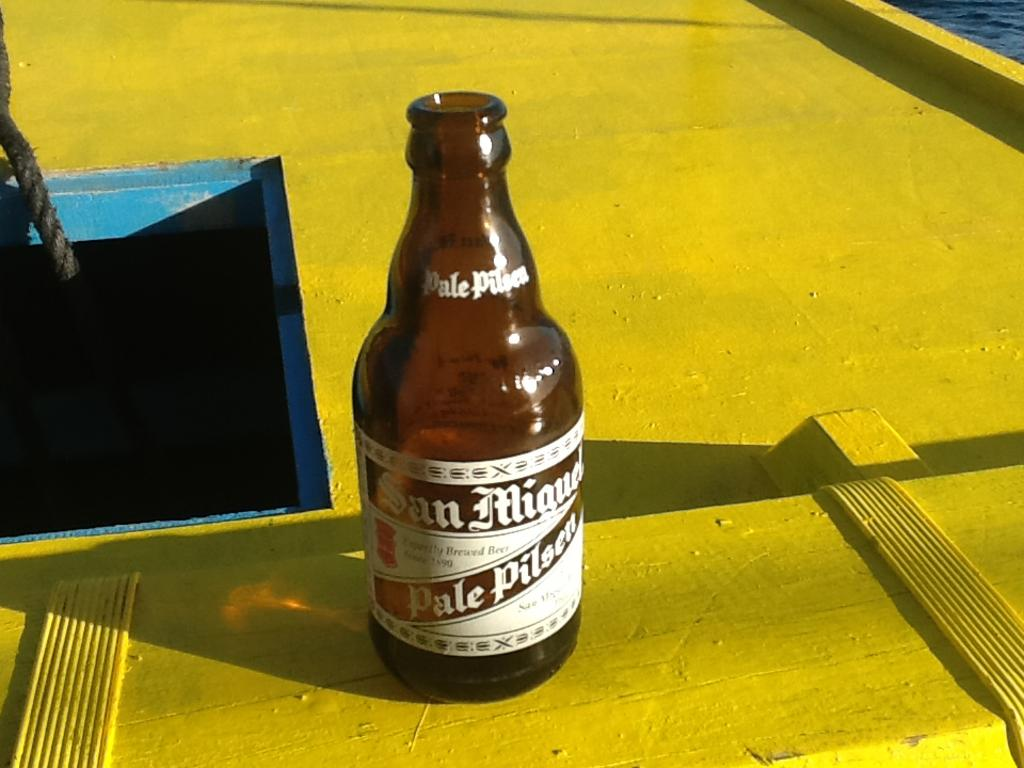<image>
Summarize the visual content of the image. A bottle of Pale Pilsner sitting on a table. 